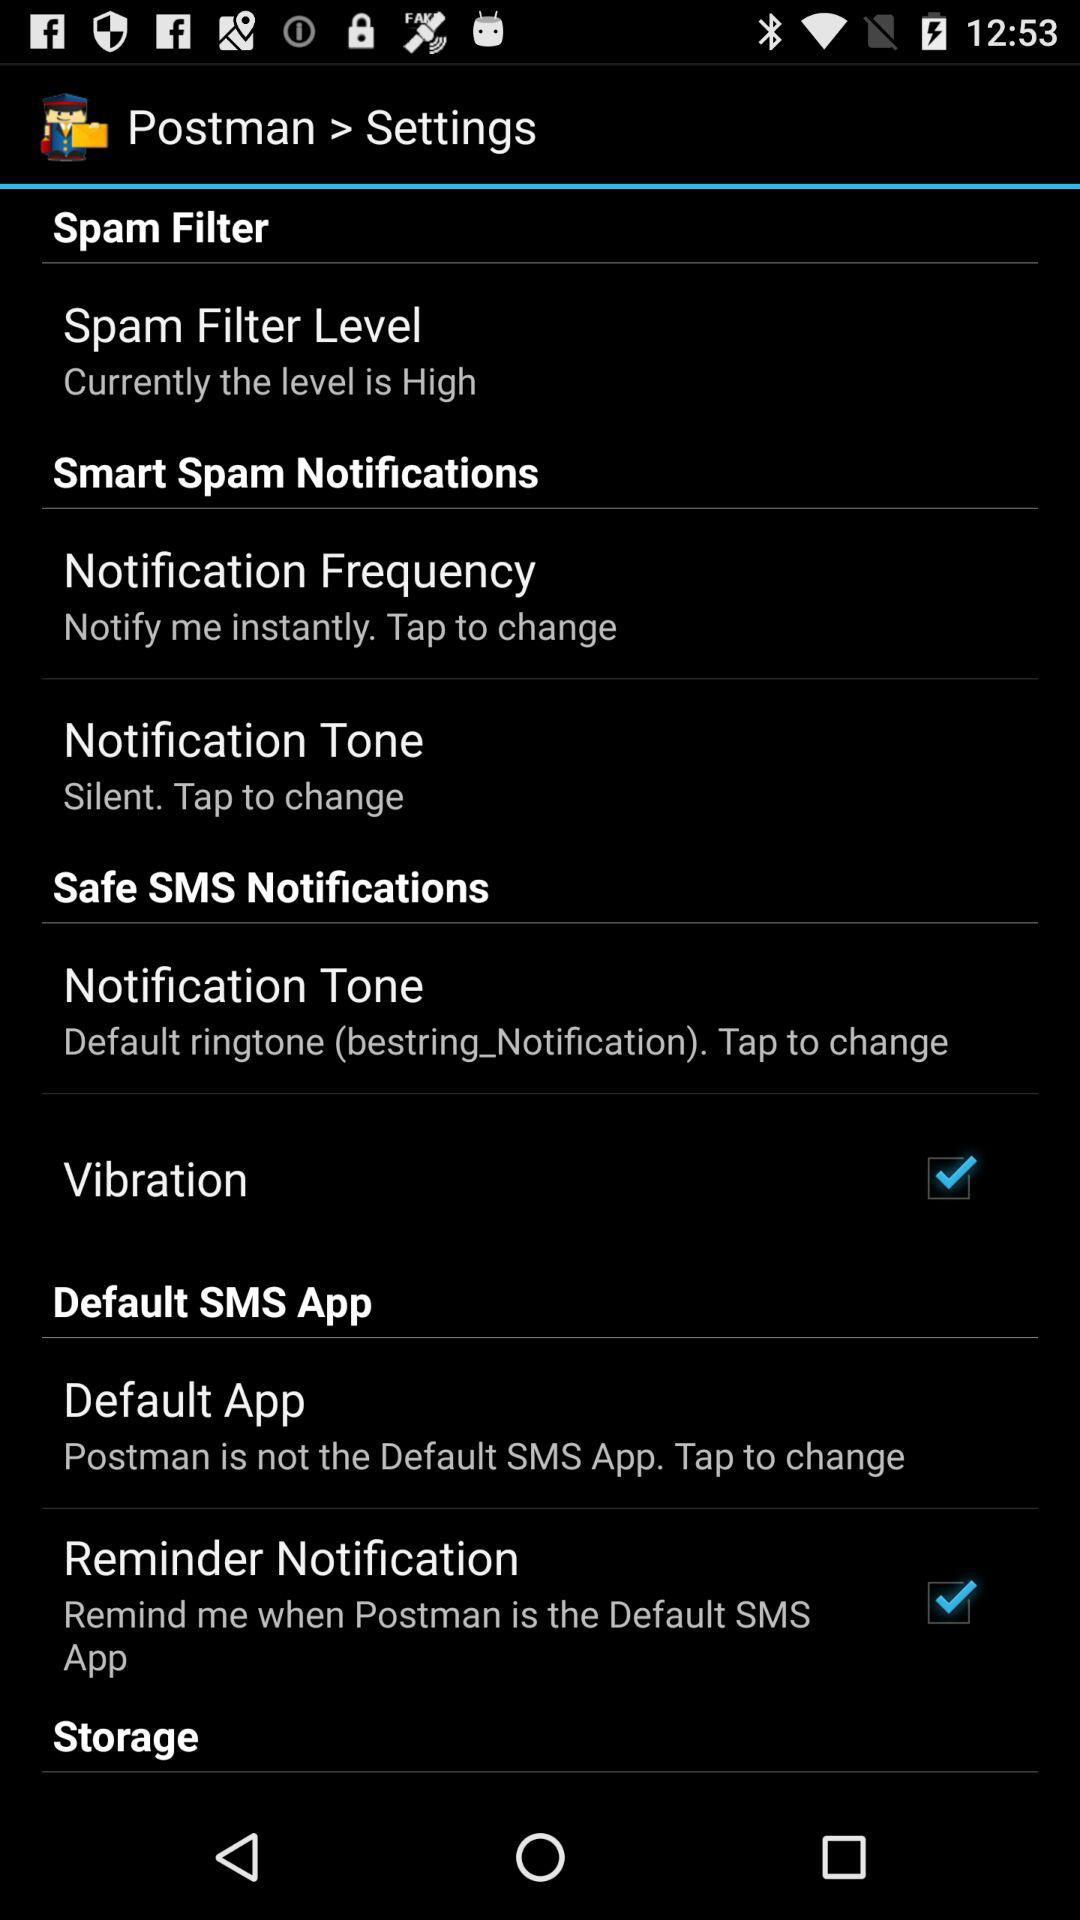What is the spam filter level? The spam filter level is high. 